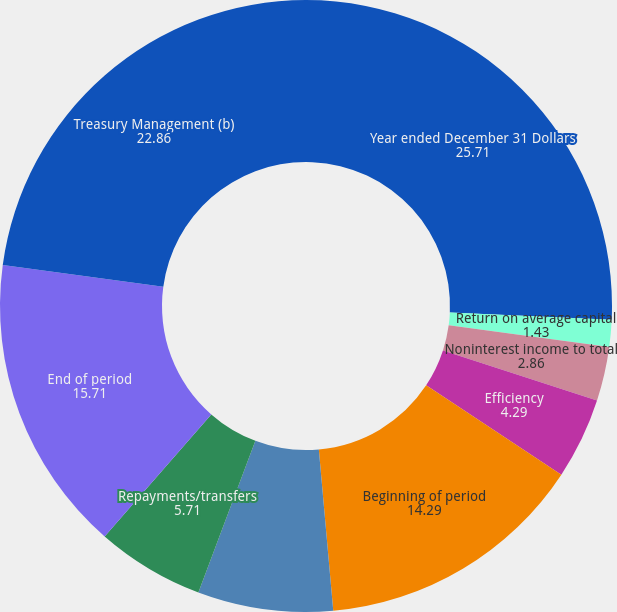Convert chart to OTSL. <chart><loc_0><loc_0><loc_500><loc_500><pie_chart><fcel>Year ended December 31 Dollars<fcel>Return on average capital<fcel>Return on average assets<fcel>Noninterest income to total<fcel>Efficiency<fcel>Beginning of period<fcel>Acquisitions/additions<fcel>Repayments/transfers<fcel>End of period<fcel>Treasury Management (b)<nl><fcel>25.71%<fcel>1.43%<fcel>0.0%<fcel>2.86%<fcel>4.29%<fcel>14.29%<fcel>7.14%<fcel>5.71%<fcel>15.71%<fcel>22.86%<nl></chart> 